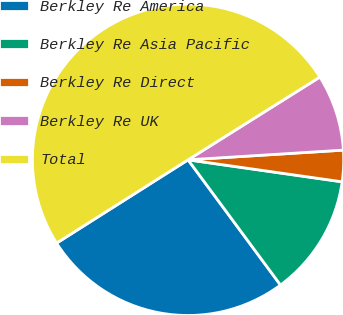Convert chart. <chart><loc_0><loc_0><loc_500><loc_500><pie_chart><fcel>Berkley Re America<fcel>Berkley Re Asia Pacific<fcel>Berkley Re Direct<fcel>Berkley Re UK<fcel>Total<nl><fcel>26.13%<fcel>12.62%<fcel>3.25%<fcel>7.93%<fcel>50.06%<nl></chart> 